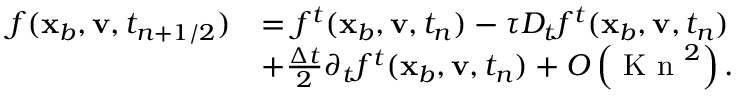Convert formula to latex. <formula><loc_0><loc_0><loc_500><loc_500>\begin{array} { r l } { f ( \mathbf x _ { b } , \mathbf v , t _ { n + 1 / 2 } ) } & { = f ^ { t } ( \mathbf x _ { b } , \mathbf v , t _ { n } ) - \tau D _ { t } f ^ { t } ( \mathbf x _ { b } , \mathbf v , t _ { n } ) } \\ & { + \frac { \Delta t } { 2 } \partial _ { t } f ^ { t } ( \mathbf x _ { b } , \mathbf v , t _ { n } ) + O \left ( K n ^ { 2 } \right ) . } \end{array}</formula> 